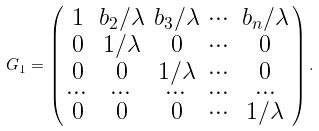<formula> <loc_0><loc_0><loc_500><loc_500>G _ { 1 } = \left ( \begin{smallmatrix} 1 & b _ { 2 } / \lambda & b _ { 3 } / \lambda & \cdots & b _ { n } / \lambda \\ 0 & 1 / \lambda & 0 & \cdots & 0 \\ 0 & 0 & 1 / \lambda & \cdots & 0 \\ \cdots & \cdots & \cdots & \cdots & \cdots \\ 0 & 0 & 0 & \cdots & 1 / \lambda \end{smallmatrix} \right ) .</formula> 